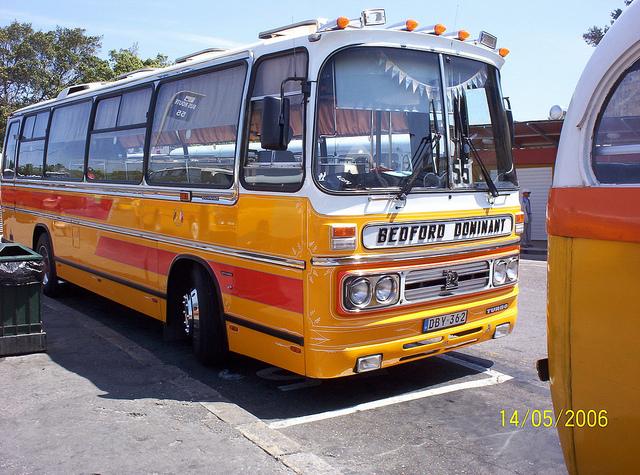What does the bus say?
Keep it brief. Bedford dominant. Was this photo taken within the last 5 years?
Write a very short answer. No. What color is this bus?
Concise answer only. Yellow. 